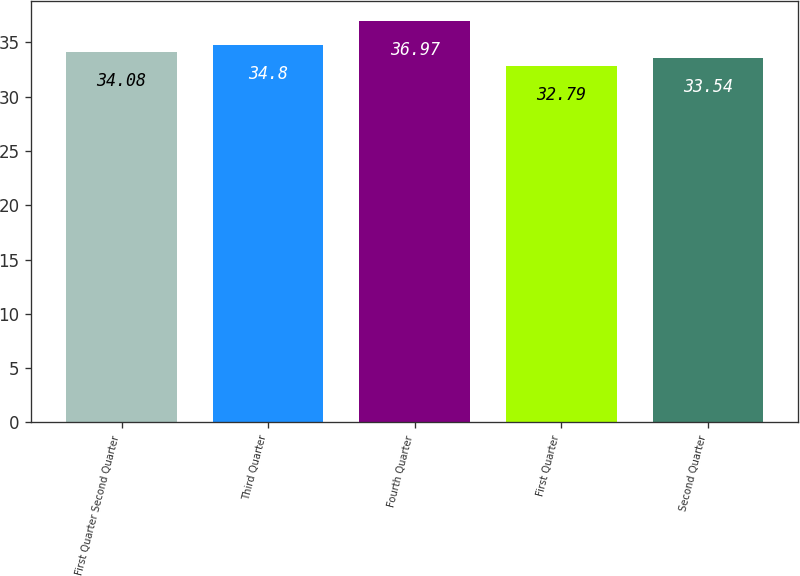Convert chart to OTSL. <chart><loc_0><loc_0><loc_500><loc_500><bar_chart><fcel>First Quarter Second Quarter<fcel>Third Quarter<fcel>Fourth Quarter<fcel>First Quarter<fcel>Second Quarter<nl><fcel>34.08<fcel>34.8<fcel>36.97<fcel>32.79<fcel>33.54<nl></chart> 